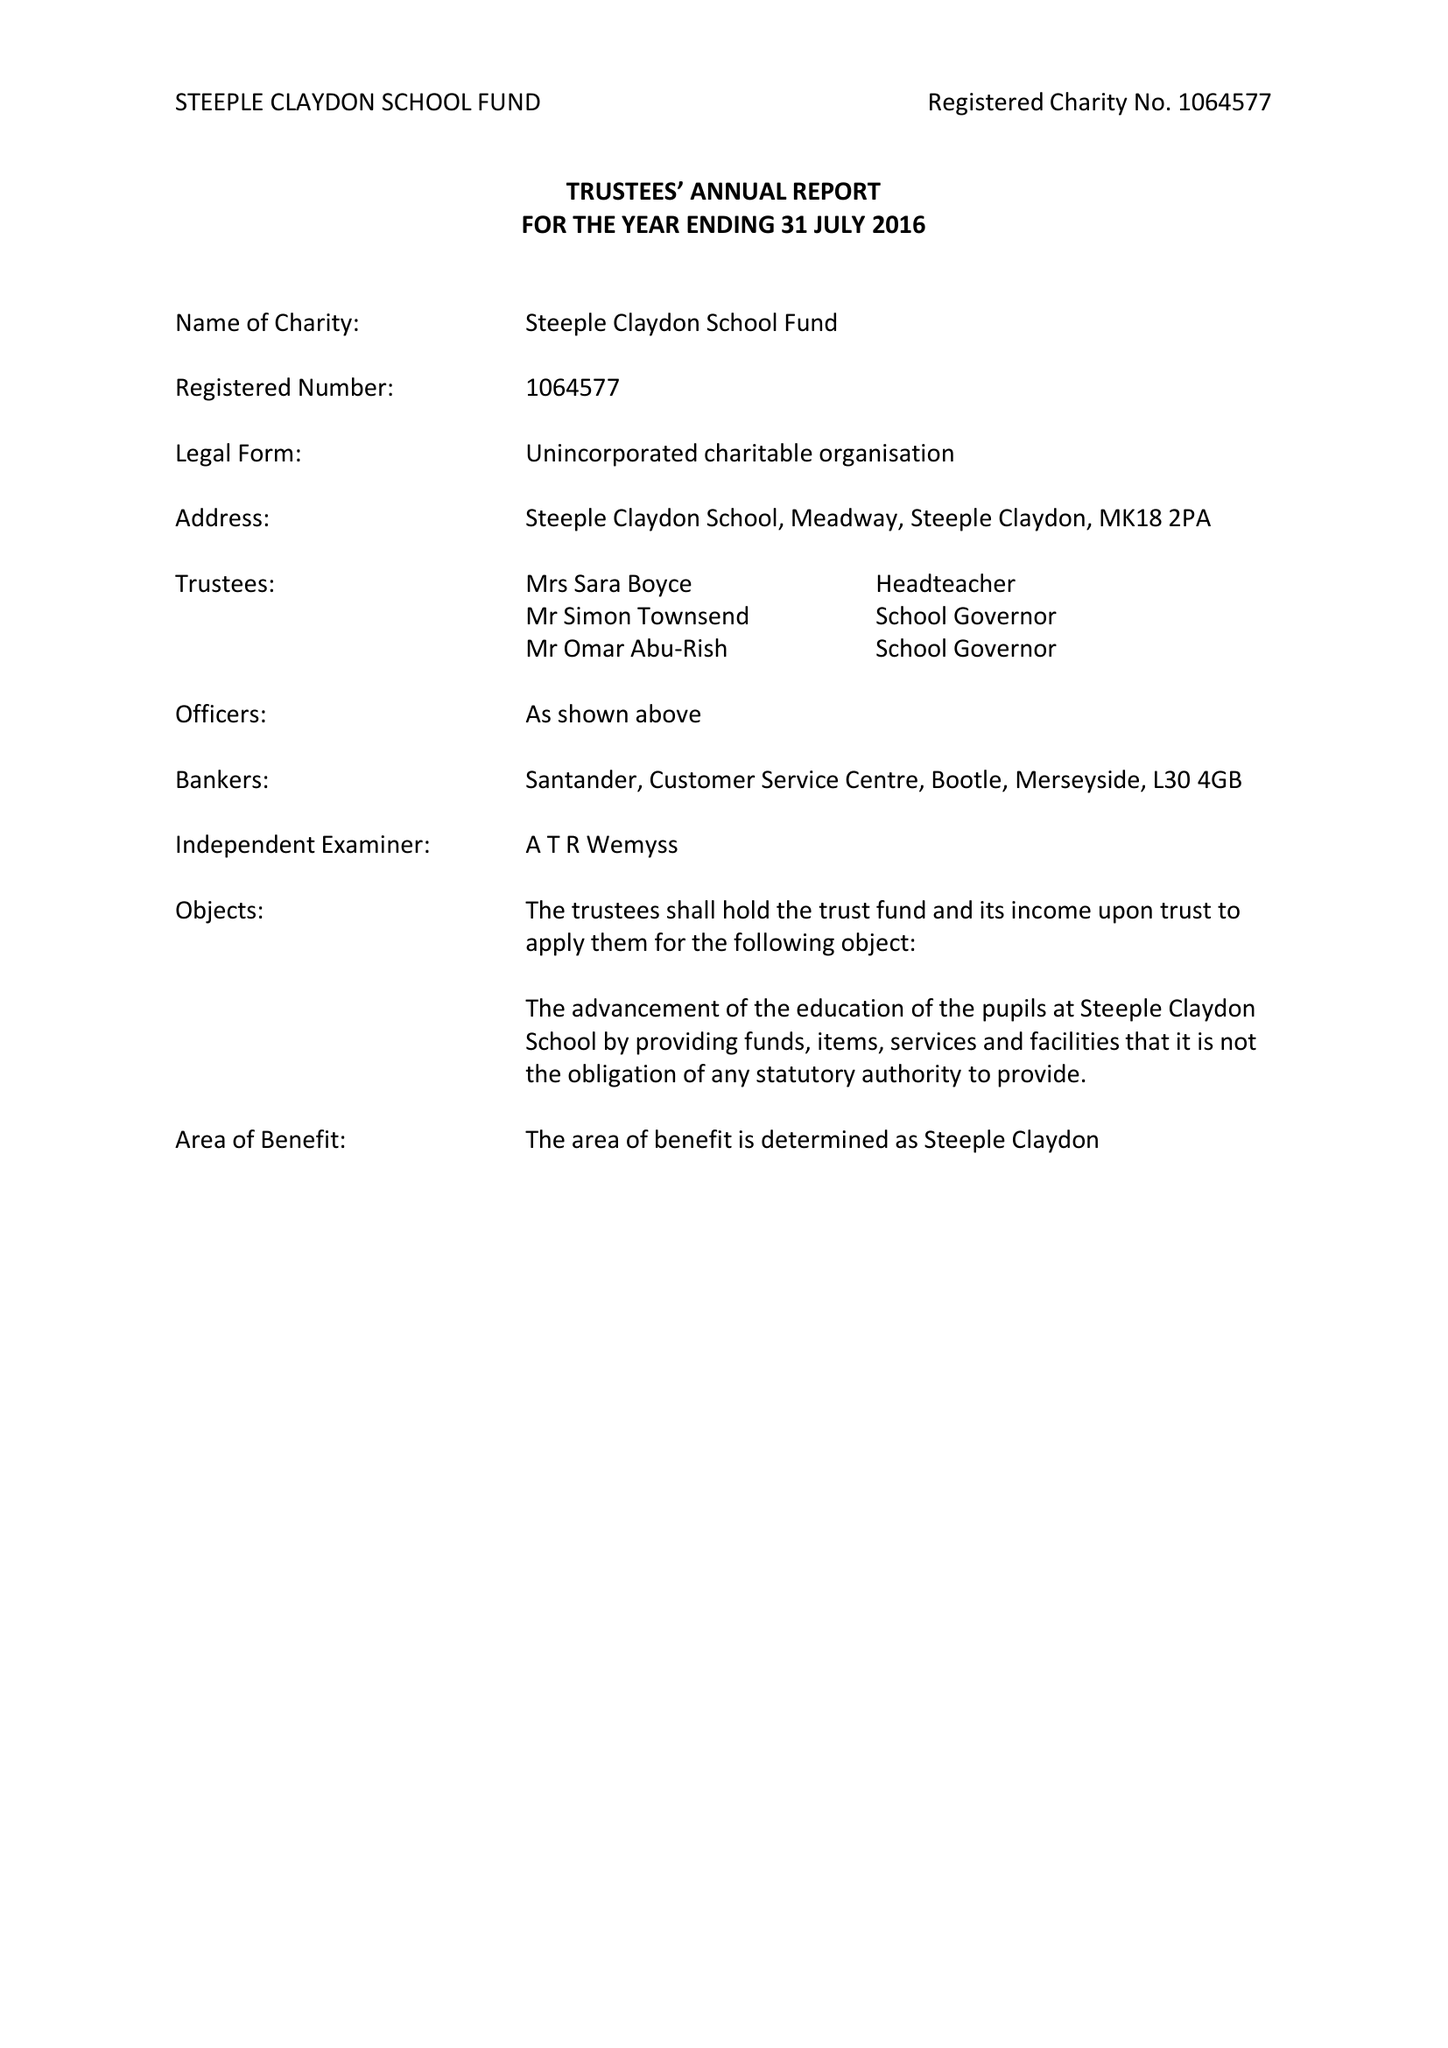What is the value for the income_annually_in_british_pounds?
Answer the question using a single word or phrase. 54742.00 